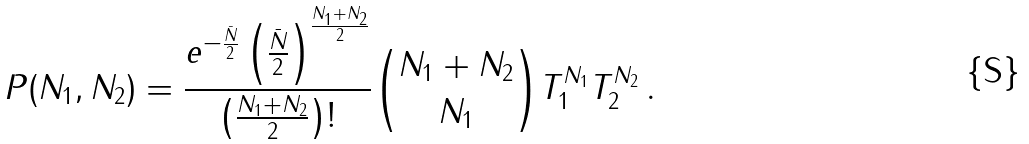Convert formula to latex. <formula><loc_0><loc_0><loc_500><loc_500>P ( N _ { 1 } , N _ { 2 } ) = \frac { e ^ { - \frac { \bar { N } } { 2 } } \left ( \frac { \bar { N } } { 2 } \right ) ^ { \frac { N _ { 1 } + N _ { 2 } } { 2 } } } { \left ( \frac { N _ { 1 } + N _ { 2 } } { 2 } \right ) ! } { { N _ { 1 } + N _ { 2 } } \choose { N _ { 1 } } } T _ { 1 } ^ { N _ { 1 } } T _ { 2 } ^ { N _ { 2 } } \, .</formula> 